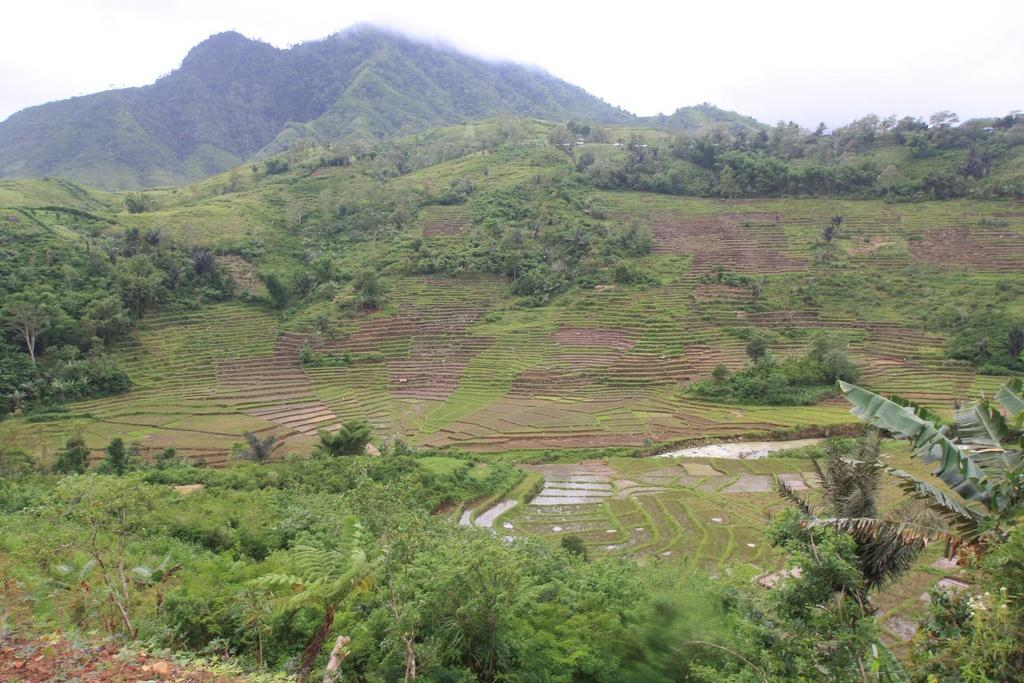What types of vegetation can be seen at the bottom of the image? There are plants, trees, and grass at the bottom of the image. What natural features are visible in the background of the image? There are mountains, trees, sand, and water visible in the background of the image. How many boys are standing in line in the image? There are no boys or lines present in the image. What type of need is being used to sew the plants in the image? There are no needles or sewing involved in the image; it features plants, trees, grass, mountains, trees, sand, and water. 